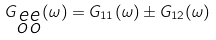<formula> <loc_0><loc_0><loc_500><loc_500>G _ { \substack { e e \\ o o } } ( \omega ) = G _ { 1 1 } ( \omega ) \pm G _ { 1 2 } ( \omega )</formula> 